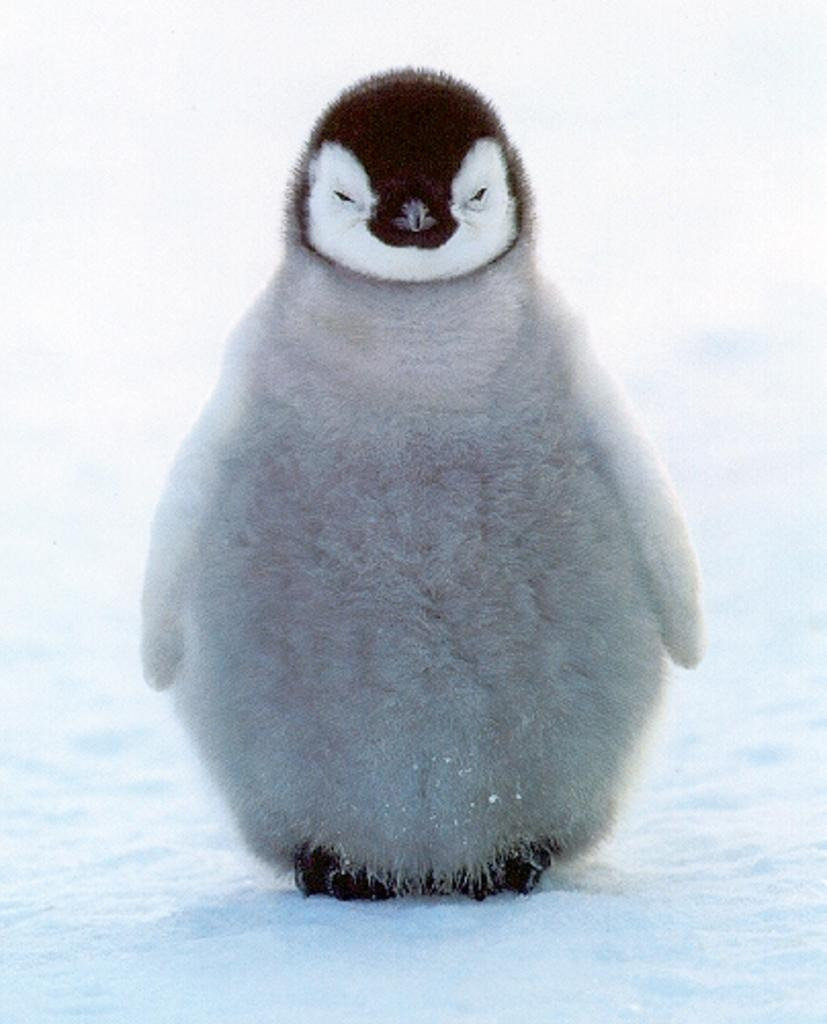What animal is featured in the picture? There is a penguin in the picture. What color is the penguin's fur? The penguin has white fur. What type of terrain is the penguin standing on? The penguin is standing on the snow. What type of wool is used to make the penguin's sweater in the image? There is no sweater or wool mentioned in the image; the penguin has white fur. How many buttons can be seen on the penguin's hat in the image? There is no hat or buttons present in the image; the penguin is standing on the snow. 